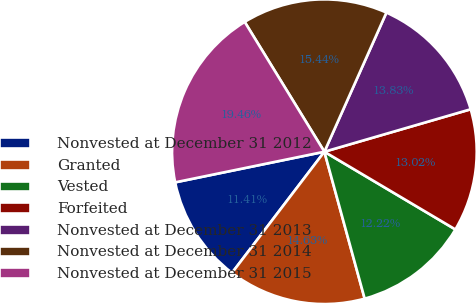<chart> <loc_0><loc_0><loc_500><loc_500><pie_chart><fcel>Nonvested at December 31 2012<fcel>Granted<fcel>Vested<fcel>Forfeited<fcel>Nonvested at December 31 2013<fcel>Nonvested at December 31 2014<fcel>Nonvested at December 31 2015<nl><fcel>11.41%<fcel>14.63%<fcel>12.22%<fcel>13.02%<fcel>13.83%<fcel>15.44%<fcel>19.46%<nl></chart> 